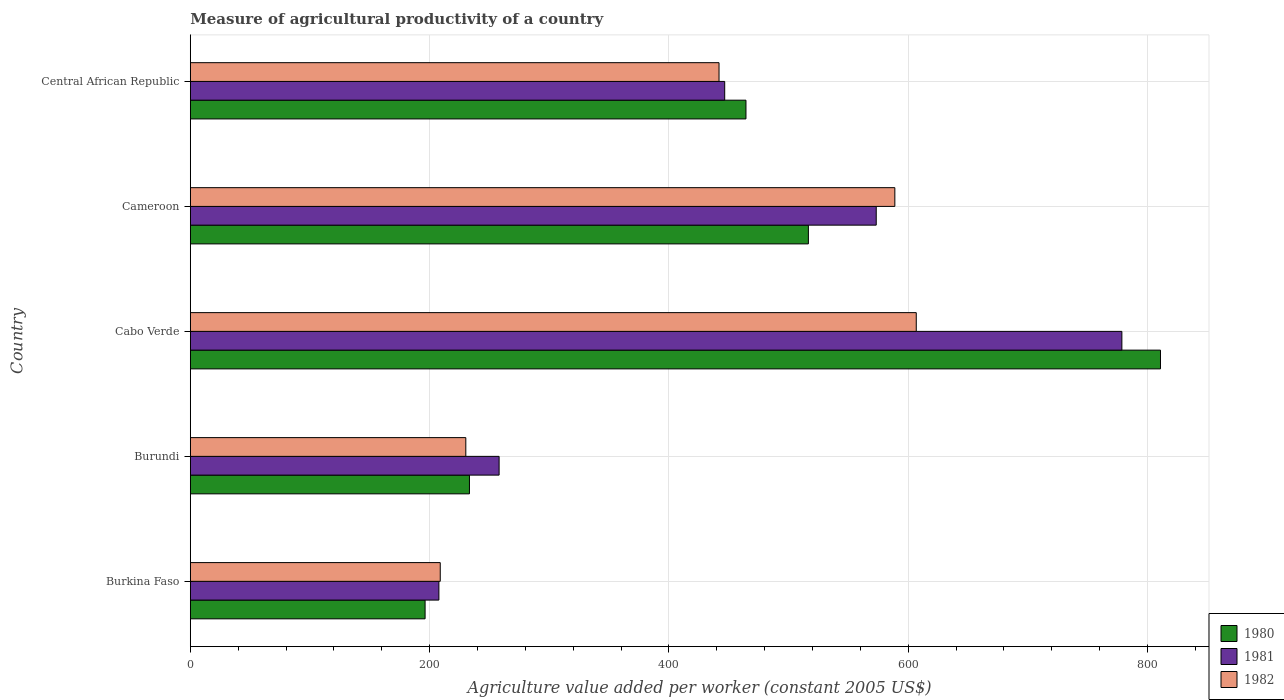How many groups of bars are there?
Ensure brevity in your answer.  5. Are the number of bars on each tick of the Y-axis equal?
Provide a succinct answer. Yes. What is the label of the 1st group of bars from the top?
Provide a succinct answer. Central African Republic. In how many cases, is the number of bars for a given country not equal to the number of legend labels?
Ensure brevity in your answer.  0. What is the measure of agricultural productivity in 1980 in Cabo Verde?
Your response must be concise. 810.9. Across all countries, what is the maximum measure of agricultural productivity in 1980?
Offer a very short reply. 810.9. Across all countries, what is the minimum measure of agricultural productivity in 1980?
Give a very brief answer. 196.25. In which country was the measure of agricultural productivity in 1981 maximum?
Your answer should be very brief. Cabo Verde. In which country was the measure of agricultural productivity in 1980 minimum?
Provide a succinct answer. Burkina Faso. What is the total measure of agricultural productivity in 1980 in the graph?
Your response must be concise. 2221.52. What is the difference between the measure of agricultural productivity in 1980 in Cabo Verde and that in Cameroon?
Offer a very short reply. 294.28. What is the difference between the measure of agricultural productivity in 1982 in Central African Republic and the measure of agricultural productivity in 1981 in Cameroon?
Your response must be concise. -131.4. What is the average measure of agricultural productivity in 1980 per country?
Your answer should be compact. 444.3. What is the difference between the measure of agricultural productivity in 1981 and measure of agricultural productivity in 1980 in Central African Republic?
Make the answer very short. -17.77. In how many countries, is the measure of agricultural productivity in 1981 greater than 760 US$?
Your response must be concise. 1. What is the ratio of the measure of agricultural productivity in 1981 in Burundi to that in Central African Republic?
Make the answer very short. 0.58. What is the difference between the highest and the second highest measure of agricultural productivity in 1982?
Ensure brevity in your answer.  17.9. What is the difference between the highest and the lowest measure of agricultural productivity in 1980?
Your response must be concise. 614.65. What does the 1st bar from the top in Burundi represents?
Provide a short and direct response. 1982. How many bars are there?
Give a very brief answer. 15. Are the values on the major ticks of X-axis written in scientific E-notation?
Provide a short and direct response. No. Does the graph contain any zero values?
Give a very brief answer. No. Does the graph contain grids?
Provide a short and direct response. Yes. Where does the legend appear in the graph?
Offer a very short reply. Bottom right. How many legend labels are there?
Your answer should be very brief. 3. How are the legend labels stacked?
Give a very brief answer. Vertical. What is the title of the graph?
Offer a terse response. Measure of agricultural productivity of a country. Does "2006" appear as one of the legend labels in the graph?
Your answer should be compact. No. What is the label or title of the X-axis?
Provide a succinct answer. Agriculture value added per worker (constant 2005 US$). What is the label or title of the Y-axis?
Offer a very short reply. Country. What is the Agriculture value added per worker (constant 2005 US$) of 1980 in Burkina Faso?
Your answer should be very brief. 196.25. What is the Agriculture value added per worker (constant 2005 US$) in 1981 in Burkina Faso?
Give a very brief answer. 207.78. What is the Agriculture value added per worker (constant 2005 US$) in 1982 in Burkina Faso?
Provide a succinct answer. 208.91. What is the Agriculture value added per worker (constant 2005 US$) of 1980 in Burundi?
Your answer should be compact. 233.32. What is the Agriculture value added per worker (constant 2005 US$) of 1981 in Burundi?
Your response must be concise. 258.11. What is the Agriculture value added per worker (constant 2005 US$) of 1982 in Burundi?
Offer a terse response. 230.29. What is the Agriculture value added per worker (constant 2005 US$) in 1980 in Cabo Verde?
Provide a succinct answer. 810.9. What is the Agriculture value added per worker (constant 2005 US$) in 1981 in Cabo Verde?
Provide a succinct answer. 778.63. What is the Agriculture value added per worker (constant 2005 US$) of 1982 in Cabo Verde?
Ensure brevity in your answer.  606.77. What is the Agriculture value added per worker (constant 2005 US$) in 1980 in Cameroon?
Provide a short and direct response. 516.62. What is the Agriculture value added per worker (constant 2005 US$) of 1981 in Cameroon?
Your answer should be compact. 573.32. What is the Agriculture value added per worker (constant 2005 US$) of 1982 in Cameroon?
Your answer should be compact. 588.87. What is the Agriculture value added per worker (constant 2005 US$) of 1980 in Central African Republic?
Make the answer very short. 464.44. What is the Agriculture value added per worker (constant 2005 US$) of 1981 in Central African Republic?
Ensure brevity in your answer.  446.67. What is the Agriculture value added per worker (constant 2005 US$) in 1982 in Central African Republic?
Offer a very short reply. 441.92. Across all countries, what is the maximum Agriculture value added per worker (constant 2005 US$) in 1980?
Provide a short and direct response. 810.9. Across all countries, what is the maximum Agriculture value added per worker (constant 2005 US$) in 1981?
Ensure brevity in your answer.  778.63. Across all countries, what is the maximum Agriculture value added per worker (constant 2005 US$) in 1982?
Give a very brief answer. 606.77. Across all countries, what is the minimum Agriculture value added per worker (constant 2005 US$) in 1980?
Offer a very short reply. 196.25. Across all countries, what is the minimum Agriculture value added per worker (constant 2005 US$) of 1981?
Provide a succinct answer. 207.78. Across all countries, what is the minimum Agriculture value added per worker (constant 2005 US$) of 1982?
Your answer should be compact. 208.91. What is the total Agriculture value added per worker (constant 2005 US$) in 1980 in the graph?
Your answer should be very brief. 2221.52. What is the total Agriculture value added per worker (constant 2005 US$) of 1981 in the graph?
Offer a very short reply. 2264.51. What is the total Agriculture value added per worker (constant 2005 US$) in 1982 in the graph?
Keep it short and to the point. 2076.76. What is the difference between the Agriculture value added per worker (constant 2005 US$) in 1980 in Burkina Faso and that in Burundi?
Make the answer very short. -37.08. What is the difference between the Agriculture value added per worker (constant 2005 US$) of 1981 in Burkina Faso and that in Burundi?
Offer a terse response. -50.33. What is the difference between the Agriculture value added per worker (constant 2005 US$) of 1982 in Burkina Faso and that in Burundi?
Give a very brief answer. -21.37. What is the difference between the Agriculture value added per worker (constant 2005 US$) in 1980 in Burkina Faso and that in Cabo Verde?
Give a very brief answer. -614.65. What is the difference between the Agriculture value added per worker (constant 2005 US$) in 1981 in Burkina Faso and that in Cabo Verde?
Your response must be concise. -570.85. What is the difference between the Agriculture value added per worker (constant 2005 US$) of 1982 in Burkina Faso and that in Cabo Verde?
Make the answer very short. -397.86. What is the difference between the Agriculture value added per worker (constant 2005 US$) in 1980 in Burkina Faso and that in Cameroon?
Offer a terse response. -320.37. What is the difference between the Agriculture value added per worker (constant 2005 US$) in 1981 in Burkina Faso and that in Cameroon?
Offer a terse response. -365.54. What is the difference between the Agriculture value added per worker (constant 2005 US$) in 1982 in Burkina Faso and that in Cameroon?
Offer a terse response. -379.96. What is the difference between the Agriculture value added per worker (constant 2005 US$) in 1980 in Burkina Faso and that in Central African Republic?
Ensure brevity in your answer.  -268.19. What is the difference between the Agriculture value added per worker (constant 2005 US$) in 1981 in Burkina Faso and that in Central African Republic?
Offer a terse response. -238.89. What is the difference between the Agriculture value added per worker (constant 2005 US$) in 1982 in Burkina Faso and that in Central African Republic?
Your response must be concise. -233.01. What is the difference between the Agriculture value added per worker (constant 2005 US$) of 1980 in Burundi and that in Cabo Verde?
Ensure brevity in your answer.  -577.57. What is the difference between the Agriculture value added per worker (constant 2005 US$) of 1981 in Burundi and that in Cabo Verde?
Make the answer very short. -520.52. What is the difference between the Agriculture value added per worker (constant 2005 US$) in 1982 in Burundi and that in Cabo Verde?
Make the answer very short. -376.49. What is the difference between the Agriculture value added per worker (constant 2005 US$) in 1980 in Burundi and that in Cameroon?
Give a very brief answer. -283.29. What is the difference between the Agriculture value added per worker (constant 2005 US$) of 1981 in Burundi and that in Cameroon?
Your answer should be very brief. -315.21. What is the difference between the Agriculture value added per worker (constant 2005 US$) of 1982 in Burundi and that in Cameroon?
Make the answer very short. -358.59. What is the difference between the Agriculture value added per worker (constant 2005 US$) in 1980 in Burundi and that in Central African Republic?
Keep it short and to the point. -231.12. What is the difference between the Agriculture value added per worker (constant 2005 US$) in 1981 in Burundi and that in Central African Republic?
Your answer should be compact. -188.56. What is the difference between the Agriculture value added per worker (constant 2005 US$) in 1982 in Burundi and that in Central African Republic?
Offer a very short reply. -211.63. What is the difference between the Agriculture value added per worker (constant 2005 US$) in 1980 in Cabo Verde and that in Cameroon?
Your answer should be very brief. 294.28. What is the difference between the Agriculture value added per worker (constant 2005 US$) in 1981 in Cabo Verde and that in Cameroon?
Make the answer very short. 205.31. What is the difference between the Agriculture value added per worker (constant 2005 US$) in 1982 in Cabo Verde and that in Cameroon?
Your answer should be very brief. 17.9. What is the difference between the Agriculture value added per worker (constant 2005 US$) of 1980 in Cabo Verde and that in Central African Republic?
Make the answer very short. 346.46. What is the difference between the Agriculture value added per worker (constant 2005 US$) of 1981 in Cabo Verde and that in Central African Republic?
Your answer should be very brief. 331.96. What is the difference between the Agriculture value added per worker (constant 2005 US$) of 1982 in Cabo Verde and that in Central African Republic?
Give a very brief answer. 164.85. What is the difference between the Agriculture value added per worker (constant 2005 US$) in 1980 in Cameroon and that in Central African Republic?
Provide a short and direct response. 52.18. What is the difference between the Agriculture value added per worker (constant 2005 US$) in 1981 in Cameroon and that in Central African Republic?
Your answer should be very brief. 126.65. What is the difference between the Agriculture value added per worker (constant 2005 US$) in 1982 in Cameroon and that in Central African Republic?
Your response must be concise. 146.95. What is the difference between the Agriculture value added per worker (constant 2005 US$) in 1980 in Burkina Faso and the Agriculture value added per worker (constant 2005 US$) in 1981 in Burundi?
Provide a short and direct response. -61.86. What is the difference between the Agriculture value added per worker (constant 2005 US$) in 1980 in Burkina Faso and the Agriculture value added per worker (constant 2005 US$) in 1982 in Burundi?
Offer a very short reply. -34.04. What is the difference between the Agriculture value added per worker (constant 2005 US$) in 1981 in Burkina Faso and the Agriculture value added per worker (constant 2005 US$) in 1982 in Burundi?
Provide a succinct answer. -22.5. What is the difference between the Agriculture value added per worker (constant 2005 US$) of 1980 in Burkina Faso and the Agriculture value added per worker (constant 2005 US$) of 1981 in Cabo Verde?
Your answer should be very brief. -582.38. What is the difference between the Agriculture value added per worker (constant 2005 US$) of 1980 in Burkina Faso and the Agriculture value added per worker (constant 2005 US$) of 1982 in Cabo Verde?
Your response must be concise. -410.52. What is the difference between the Agriculture value added per worker (constant 2005 US$) in 1981 in Burkina Faso and the Agriculture value added per worker (constant 2005 US$) in 1982 in Cabo Verde?
Ensure brevity in your answer.  -398.99. What is the difference between the Agriculture value added per worker (constant 2005 US$) in 1980 in Burkina Faso and the Agriculture value added per worker (constant 2005 US$) in 1981 in Cameroon?
Make the answer very short. -377.07. What is the difference between the Agriculture value added per worker (constant 2005 US$) in 1980 in Burkina Faso and the Agriculture value added per worker (constant 2005 US$) in 1982 in Cameroon?
Offer a terse response. -392.63. What is the difference between the Agriculture value added per worker (constant 2005 US$) of 1981 in Burkina Faso and the Agriculture value added per worker (constant 2005 US$) of 1982 in Cameroon?
Make the answer very short. -381.09. What is the difference between the Agriculture value added per worker (constant 2005 US$) in 1980 in Burkina Faso and the Agriculture value added per worker (constant 2005 US$) in 1981 in Central African Republic?
Your answer should be compact. -250.42. What is the difference between the Agriculture value added per worker (constant 2005 US$) in 1980 in Burkina Faso and the Agriculture value added per worker (constant 2005 US$) in 1982 in Central African Republic?
Keep it short and to the point. -245.67. What is the difference between the Agriculture value added per worker (constant 2005 US$) in 1981 in Burkina Faso and the Agriculture value added per worker (constant 2005 US$) in 1982 in Central African Republic?
Offer a terse response. -234.14. What is the difference between the Agriculture value added per worker (constant 2005 US$) in 1980 in Burundi and the Agriculture value added per worker (constant 2005 US$) in 1981 in Cabo Verde?
Provide a succinct answer. -545.31. What is the difference between the Agriculture value added per worker (constant 2005 US$) in 1980 in Burundi and the Agriculture value added per worker (constant 2005 US$) in 1982 in Cabo Verde?
Provide a succinct answer. -373.45. What is the difference between the Agriculture value added per worker (constant 2005 US$) in 1981 in Burundi and the Agriculture value added per worker (constant 2005 US$) in 1982 in Cabo Verde?
Give a very brief answer. -348.66. What is the difference between the Agriculture value added per worker (constant 2005 US$) in 1980 in Burundi and the Agriculture value added per worker (constant 2005 US$) in 1981 in Cameroon?
Ensure brevity in your answer.  -340. What is the difference between the Agriculture value added per worker (constant 2005 US$) in 1980 in Burundi and the Agriculture value added per worker (constant 2005 US$) in 1982 in Cameroon?
Provide a short and direct response. -355.55. What is the difference between the Agriculture value added per worker (constant 2005 US$) in 1981 in Burundi and the Agriculture value added per worker (constant 2005 US$) in 1982 in Cameroon?
Ensure brevity in your answer.  -330.76. What is the difference between the Agriculture value added per worker (constant 2005 US$) of 1980 in Burundi and the Agriculture value added per worker (constant 2005 US$) of 1981 in Central African Republic?
Ensure brevity in your answer.  -213.35. What is the difference between the Agriculture value added per worker (constant 2005 US$) of 1980 in Burundi and the Agriculture value added per worker (constant 2005 US$) of 1982 in Central African Republic?
Your answer should be compact. -208.6. What is the difference between the Agriculture value added per worker (constant 2005 US$) in 1981 in Burundi and the Agriculture value added per worker (constant 2005 US$) in 1982 in Central African Republic?
Give a very brief answer. -183.81. What is the difference between the Agriculture value added per worker (constant 2005 US$) of 1980 in Cabo Verde and the Agriculture value added per worker (constant 2005 US$) of 1981 in Cameroon?
Make the answer very short. 237.58. What is the difference between the Agriculture value added per worker (constant 2005 US$) of 1980 in Cabo Verde and the Agriculture value added per worker (constant 2005 US$) of 1982 in Cameroon?
Your answer should be very brief. 222.02. What is the difference between the Agriculture value added per worker (constant 2005 US$) in 1981 in Cabo Verde and the Agriculture value added per worker (constant 2005 US$) in 1982 in Cameroon?
Provide a short and direct response. 189.76. What is the difference between the Agriculture value added per worker (constant 2005 US$) in 1980 in Cabo Verde and the Agriculture value added per worker (constant 2005 US$) in 1981 in Central African Republic?
Your answer should be compact. 364.23. What is the difference between the Agriculture value added per worker (constant 2005 US$) of 1980 in Cabo Verde and the Agriculture value added per worker (constant 2005 US$) of 1982 in Central African Republic?
Your response must be concise. 368.98. What is the difference between the Agriculture value added per worker (constant 2005 US$) in 1981 in Cabo Verde and the Agriculture value added per worker (constant 2005 US$) in 1982 in Central African Republic?
Offer a terse response. 336.71. What is the difference between the Agriculture value added per worker (constant 2005 US$) of 1980 in Cameroon and the Agriculture value added per worker (constant 2005 US$) of 1981 in Central African Republic?
Give a very brief answer. 69.94. What is the difference between the Agriculture value added per worker (constant 2005 US$) of 1980 in Cameroon and the Agriculture value added per worker (constant 2005 US$) of 1982 in Central African Republic?
Offer a terse response. 74.7. What is the difference between the Agriculture value added per worker (constant 2005 US$) in 1981 in Cameroon and the Agriculture value added per worker (constant 2005 US$) in 1982 in Central African Republic?
Ensure brevity in your answer.  131.4. What is the average Agriculture value added per worker (constant 2005 US$) of 1980 per country?
Ensure brevity in your answer.  444.3. What is the average Agriculture value added per worker (constant 2005 US$) of 1981 per country?
Offer a terse response. 452.9. What is the average Agriculture value added per worker (constant 2005 US$) in 1982 per country?
Make the answer very short. 415.35. What is the difference between the Agriculture value added per worker (constant 2005 US$) of 1980 and Agriculture value added per worker (constant 2005 US$) of 1981 in Burkina Faso?
Give a very brief answer. -11.54. What is the difference between the Agriculture value added per worker (constant 2005 US$) of 1980 and Agriculture value added per worker (constant 2005 US$) of 1982 in Burkina Faso?
Your response must be concise. -12.66. What is the difference between the Agriculture value added per worker (constant 2005 US$) in 1981 and Agriculture value added per worker (constant 2005 US$) in 1982 in Burkina Faso?
Your answer should be very brief. -1.13. What is the difference between the Agriculture value added per worker (constant 2005 US$) of 1980 and Agriculture value added per worker (constant 2005 US$) of 1981 in Burundi?
Offer a terse response. -24.79. What is the difference between the Agriculture value added per worker (constant 2005 US$) in 1980 and Agriculture value added per worker (constant 2005 US$) in 1982 in Burundi?
Your answer should be compact. 3.04. What is the difference between the Agriculture value added per worker (constant 2005 US$) in 1981 and Agriculture value added per worker (constant 2005 US$) in 1982 in Burundi?
Your answer should be very brief. 27.82. What is the difference between the Agriculture value added per worker (constant 2005 US$) of 1980 and Agriculture value added per worker (constant 2005 US$) of 1981 in Cabo Verde?
Offer a very short reply. 32.27. What is the difference between the Agriculture value added per worker (constant 2005 US$) of 1980 and Agriculture value added per worker (constant 2005 US$) of 1982 in Cabo Verde?
Ensure brevity in your answer.  204.13. What is the difference between the Agriculture value added per worker (constant 2005 US$) of 1981 and Agriculture value added per worker (constant 2005 US$) of 1982 in Cabo Verde?
Offer a very short reply. 171.86. What is the difference between the Agriculture value added per worker (constant 2005 US$) in 1980 and Agriculture value added per worker (constant 2005 US$) in 1981 in Cameroon?
Offer a very short reply. -56.7. What is the difference between the Agriculture value added per worker (constant 2005 US$) of 1980 and Agriculture value added per worker (constant 2005 US$) of 1982 in Cameroon?
Provide a succinct answer. -72.26. What is the difference between the Agriculture value added per worker (constant 2005 US$) in 1981 and Agriculture value added per worker (constant 2005 US$) in 1982 in Cameroon?
Your answer should be compact. -15.55. What is the difference between the Agriculture value added per worker (constant 2005 US$) of 1980 and Agriculture value added per worker (constant 2005 US$) of 1981 in Central African Republic?
Ensure brevity in your answer.  17.77. What is the difference between the Agriculture value added per worker (constant 2005 US$) in 1980 and Agriculture value added per worker (constant 2005 US$) in 1982 in Central African Republic?
Ensure brevity in your answer.  22.52. What is the difference between the Agriculture value added per worker (constant 2005 US$) in 1981 and Agriculture value added per worker (constant 2005 US$) in 1982 in Central African Republic?
Your answer should be compact. 4.75. What is the ratio of the Agriculture value added per worker (constant 2005 US$) of 1980 in Burkina Faso to that in Burundi?
Provide a short and direct response. 0.84. What is the ratio of the Agriculture value added per worker (constant 2005 US$) of 1981 in Burkina Faso to that in Burundi?
Provide a short and direct response. 0.81. What is the ratio of the Agriculture value added per worker (constant 2005 US$) of 1982 in Burkina Faso to that in Burundi?
Ensure brevity in your answer.  0.91. What is the ratio of the Agriculture value added per worker (constant 2005 US$) of 1980 in Burkina Faso to that in Cabo Verde?
Offer a terse response. 0.24. What is the ratio of the Agriculture value added per worker (constant 2005 US$) of 1981 in Burkina Faso to that in Cabo Verde?
Give a very brief answer. 0.27. What is the ratio of the Agriculture value added per worker (constant 2005 US$) of 1982 in Burkina Faso to that in Cabo Verde?
Provide a succinct answer. 0.34. What is the ratio of the Agriculture value added per worker (constant 2005 US$) in 1980 in Burkina Faso to that in Cameroon?
Give a very brief answer. 0.38. What is the ratio of the Agriculture value added per worker (constant 2005 US$) in 1981 in Burkina Faso to that in Cameroon?
Make the answer very short. 0.36. What is the ratio of the Agriculture value added per worker (constant 2005 US$) of 1982 in Burkina Faso to that in Cameroon?
Offer a very short reply. 0.35. What is the ratio of the Agriculture value added per worker (constant 2005 US$) in 1980 in Burkina Faso to that in Central African Republic?
Provide a succinct answer. 0.42. What is the ratio of the Agriculture value added per worker (constant 2005 US$) in 1981 in Burkina Faso to that in Central African Republic?
Your answer should be very brief. 0.47. What is the ratio of the Agriculture value added per worker (constant 2005 US$) in 1982 in Burkina Faso to that in Central African Republic?
Offer a very short reply. 0.47. What is the ratio of the Agriculture value added per worker (constant 2005 US$) of 1980 in Burundi to that in Cabo Verde?
Ensure brevity in your answer.  0.29. What is the ratio of the Agriculture value added per worker (constant 2005 US$) of 1981 in Burundi to that in Cabo Verde?
Offer a terse response. 0.33. What is the ratio of the Agriculture value added per worker (constant 2005 US$) in 1982 in Burundi to that in Cabo Verde?
Keep it short and to the point. 0.38. What is the ratio of the Agriculture value added per worker (constant 2005 US$) of 1980 in Burundi to that in Cameroon?
Offer a terse response. 0.45. What is the ratio of the Agriculture value added per worker (constant 2005 US$) in 1981 in Burundi to that in Cameroon?
Your answer should be compact. 0.45. What is the ratio of the Agriculture value added per worker (constant 2005 US$) in 1982 in Burundi to that in Cameroon?
Offer a terse response. 0.39. What is the ratio of the Agriculture value added per worker (constant 2005 US$) of 1980 in Burundi to that in Central African Republic?
Your answer should be very brief. 0.5. What is the ratio of the Agriculture value added per worker (constant 2005 US$) of 1981 in Burundi to that in Central African Republic?
Offer a very short reply. 0.58. What is the ratio of the Agriculture value added per worker (constant 2005 US$) of 1982 in Burundi to that in Central African Republic?
Provide a short and direct response. 0.52. What is the ratio of the Agriculture value added per worker (constant 2005 US$) in 1980 in Cabo Verde to that in Cameroon?
Your response must be concise. 1.57. What is the ratio of the Agriculture value added per worker (constant 2005 US$) in 1981 in Cabo Verde to that in Cameroon?
Provide a short and direct response. 1.36. What is the ratio of the Agriculture value added per worker (constant 2005 US$) in 1982 in Cabo Verde to that in Cameroon?
Provide a short and direct response. 1.03. What is the ratio of the Agriculture value added per worker (constant 2005 US$) of 1980 in Cabo Verde to that in Central African Republic?
Keep it short and to the point. 1.75. What is the ratio of the Agriculture value added per worker (constant 2005 US$) in 1981 in Cabo Verde to that in Central African Republic?
Provide a short and direct response. 1.74. What is the ratio of the Agriculture value added per worker (constant 2005 US$) in 1982 in Cabo Verde to that in Central African Republic?
Offer a terse response. 1.37. What is the ratio of the Agriculture value added per worker (constant 2005 US$) in 1980 in Cameroon to that in Central African Republic?
Ensure brevity in your answer.  1.11. What is the ratio of the Agriculture value added per worker (constant 2005 US$) in 1981 in Cameroon to that in Central African Republic?
Offer a very short reply. 1.28. What is the ratio of the Agriculture value added per worker (constant 2005 US$) of 1982 in Cameroon to that in Central African Republic?
Provide a succinct answer. 1.33. What is the difference between the highest and the second highest Agriculture value added per worker (constant 2005 US$) of 1980?
Your answer should be very brief. 294.28. What is the difference between the highest and the second highest Agriculture value added per worker (constant 2005 US$) of 1981?
Keep it short and to the point. 205.31. What is the difference between the highest and the second highest Agriculture value added per worker (constant 2005 US$) of 1982?
Ensure brevity in your answer.  17.9. What is the difference between the highest and the lowest Agriculture value added per worker (constant 2005 US$) in 1980?
Keep it short and to the point. 614.65. What is the difference between the highest and the lowest Agriculture value added per worker (constant 2005 US$) in 1981?
Make the answer very short. 570.85. What is the difference between the highest and the lowest Agriculture value added per worker (constant 2005 US$) of 1982?
Make the answer very short. 397.86. 